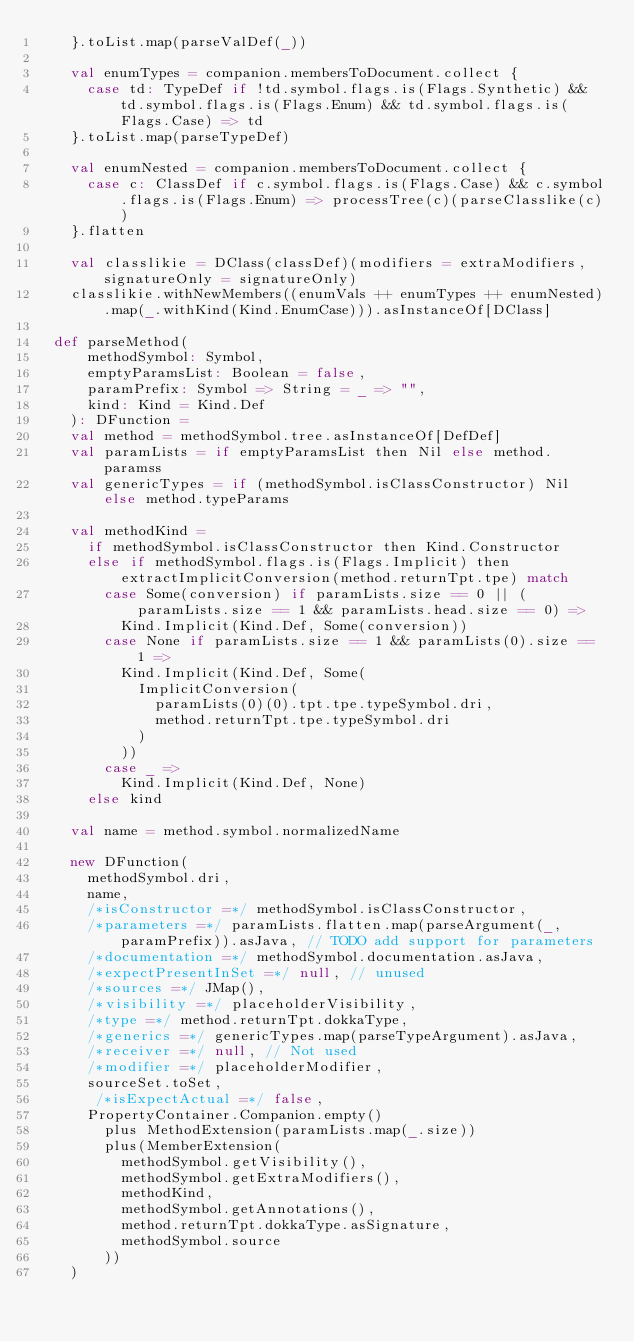Convert code to text. <code><loc_0><loc_0><loc_500><loc_500><_Scala_>    }.toList.map(parseValDef(_))

    val enumTypes = companion.membersToDocument.collect {
      case td: TypeDef if !td.symbol.flags.is(Flags.Synthetic) && td.symbol.flags.is(Flags.Enum) && td.symbol.flags.is(Flags.Case) => td
    }.toList.map(parseTypeDef)

    val enumNested = companion.membersToDocument.collect {
      case c: ClassDef if c.symbol.flags.is(Flags.Case) && c.symbol.flags.is(Flags.Enum) => processTree(c)(parseClasslike(c))
    }.flatten

    val classlikie = DClass(classDef)(modifiers = extraModifiers, signatureOnly = signatureOnly)
    classlikie.withNewMembers((enumVals ++ enumTypes ++ enumNested).map(_.withKind(Kind.EnumCase))).asInstanceOf[DClass]

  def parseMethod(
      methodSymbol: Symbol,
      emptyParamsList: Boolean = false,
      paramPrefix: Symbol => String = _ => "",
      kind: Kind = Kind.Def
    ): DFunction =
    val method = methodSymbol.tree.asInstanceOf[DefDef]
    val paramLists = if emptyParamsList then Nil else method.paramss
    val genericTypes = if (methodSymbol.isClassConstructor) Nil else method.typeParams

    val methodKind =
      if methodSymbol.isClassConstructor then Kind.Constructor
      else if methodSymbol.flags.is(Flags.Implicit) then extractImplicitConversion(method.returnTpt.tpe) match
        case Some(conversion) if paramLists.size == 0 || (paramLists.size == 1 && paramLists.head.size == 0) =>
          Kind.Implicit(Kind.Def, Some(conversion))
        case None if paramLists.size == 1 && paramLists(0).size == 1 =>
          Kind.Implicit(Kind.Def, Some(
            ImplicitConversion(
              paramLists(0)(0).tpt.tpe.typeSymbol.dri,
              method.returnTpt.tpe.typeSymbol.dri
            )
          ))
        case _ =>
          Kind.Implicit(Kind.Def, None)
      else kind

    val name = method.symbol.normalizedName

    new DFunction(
      methodSymbol.dri,
      name,
      /*isConstructor =*/ methodSymbol.isClassConstructor,
      /*parameters =*/ paramLists.flatten.map(parseArgument(_, paramPrefix)).asJava, // TODO add support for parameters
      /*documentation =*/ methodSymbol.documentation.asJava,
      /*expectPresentInSet =*/ null, // unused
      /*sources =*/ JMap(),
      /*visibility =*/ placeholderVisibility,
      /*type =*/ method.returnTpt.dokkaType,
      /*generics =*/ genericTypes.map(parseTypeArgument).asJava,
      /*receiver =*/ null, // Not used
      /*modifier =*/ placeholderModifier,
      sourceSet.toSet,
       /*isExpectActual =*/ false,
      PropertyContainer.Companion.empty()
        plus MethodExtension(paramLists.map(_.size))
        plus(MemberExtension(
          methodSymbol.getVisibility(),
          methodSymbol.getExtraModifiers(),
          methodKind,
          methodSymbol.getAnnotations(),
          method.returnTpt.dokkaType.asSignature,
          methodSymbol.source
        ))
    )
</code> 